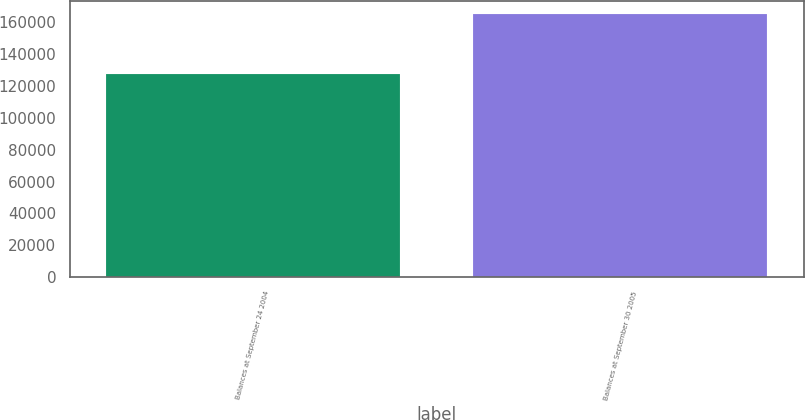<chart> <loc_0><loc_0><loc_500><loc_500><bar_chart><fcel>Balances at September 24 2004<fcel>Balances at September 30 2005<nl><fcel>127405<fcel>165074<nl></chart> 